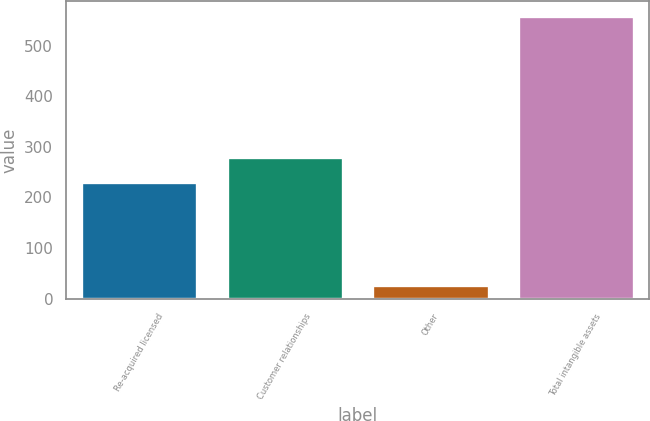<chart> <loc_0><loc_0><loc_500><loc_500><bar_chart><fcel>Re-acquired licensed<fcel>Customer relationships<fcel>Other<fcel>Total intangible assets<nl><fcel>231.1<fcel>280.15<fcel>26.9<fcel>559.15<nl></chart> 